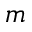<formula> <loc_0><loc_0><loc_500><loc_500>m</formula> 